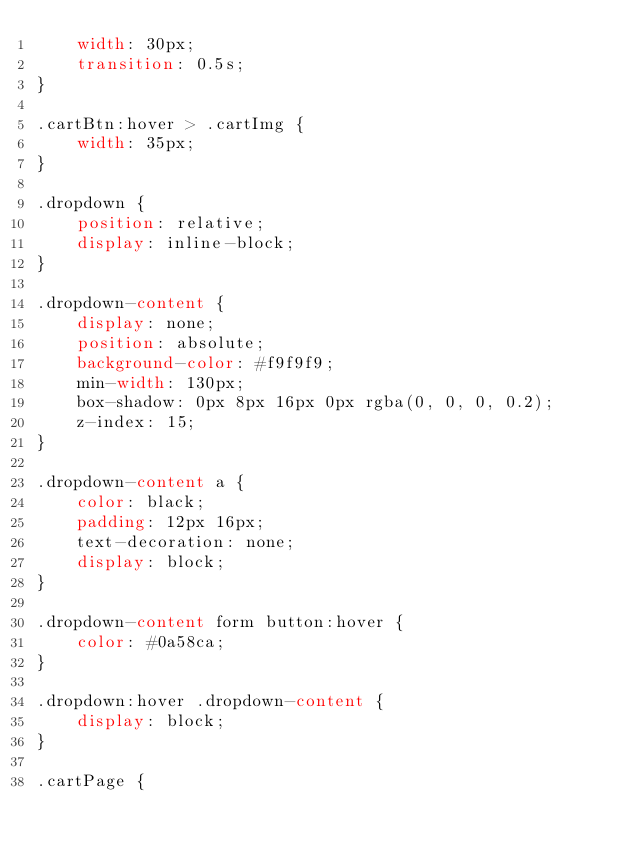<code> <loc_0><loc_0><loc_500><loc_500><_CSS_>    width: 30px;
    transition: 0.5s;
}

.cartBtn:hover > .cartImg {
    width: 35px;
}

.dropdown {
    position: relative;
    display: inline-block;
}

.dropdown-content {
    display: none;
    position: absolute;
    background-color: #f9f9f9;
    min-width: 130px;
    box-shadow: 0px 8px 16px 0px rgba(0, 0, 0, 0.2);
    z-index: 15;
}

.dropdown-content a {
    color: black;
    padding: 12px 16px;
    text-decoration: none;
    display: block;
}

.dropdown-content form button:hover {
    color: #0a58ca;
}

.dropdown:hover .dropdown-content {
    display: block;
}

.cartPage {</code> 